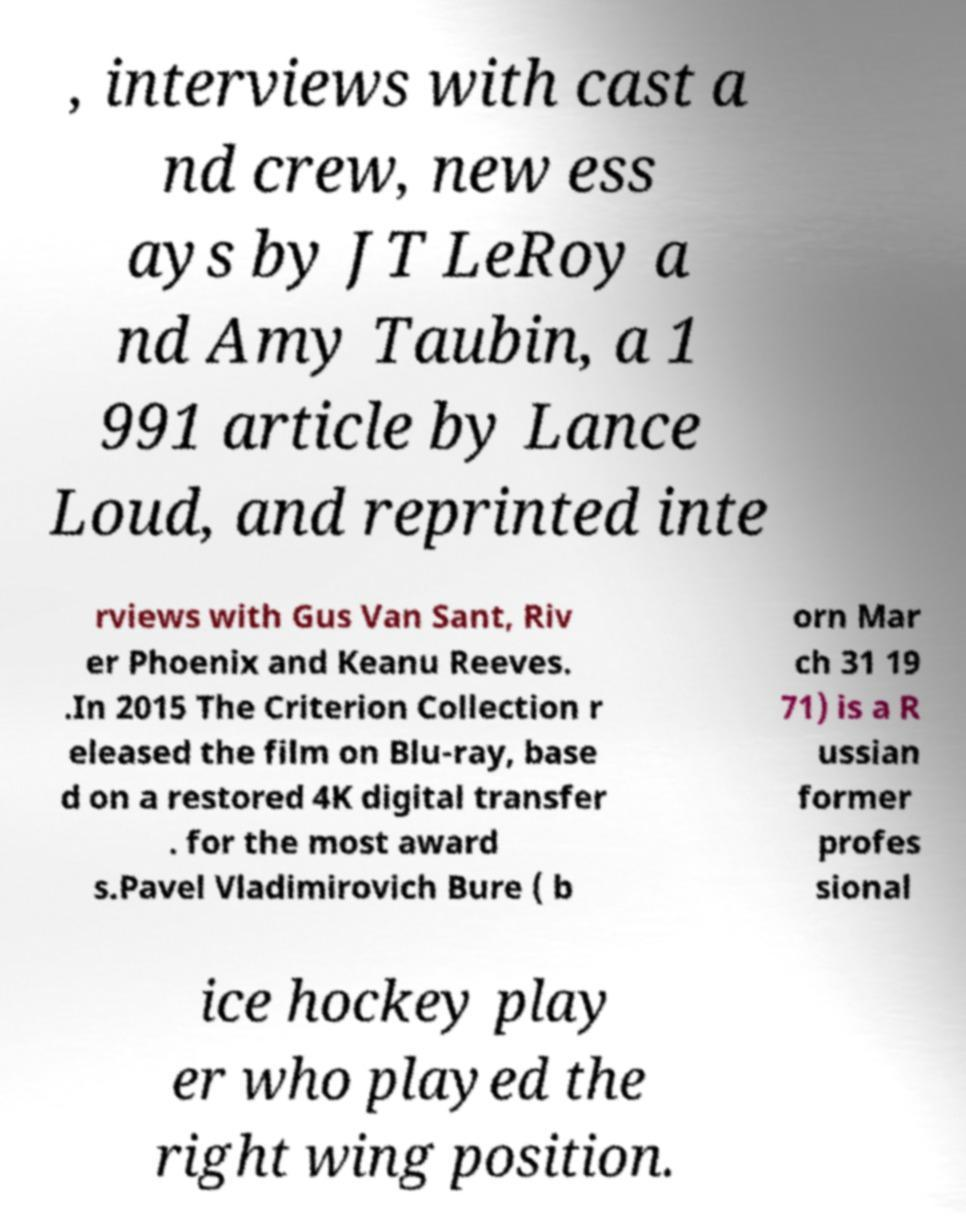What messages or text are displayed in this image? I need them in a readable, typed format. , interviews with cast a nd crew, new ess ays by JT LeRoy a nd Amy Taubin, a 1 991 article by Lance Loud, and reprinted inte rviews with Gus Van Sant, Riv er Phoenix and Keanu Reeves. .In 2015 The Criterion Collection r eleased the film on Blu-ray, base d on a restored 4K digital transfer . for the most award s.Pavel Vladimirovich Bure ( b orn Mar ch 31 19 71) is a R ussian former profes sional ice hockey play er who played the right wing position. 